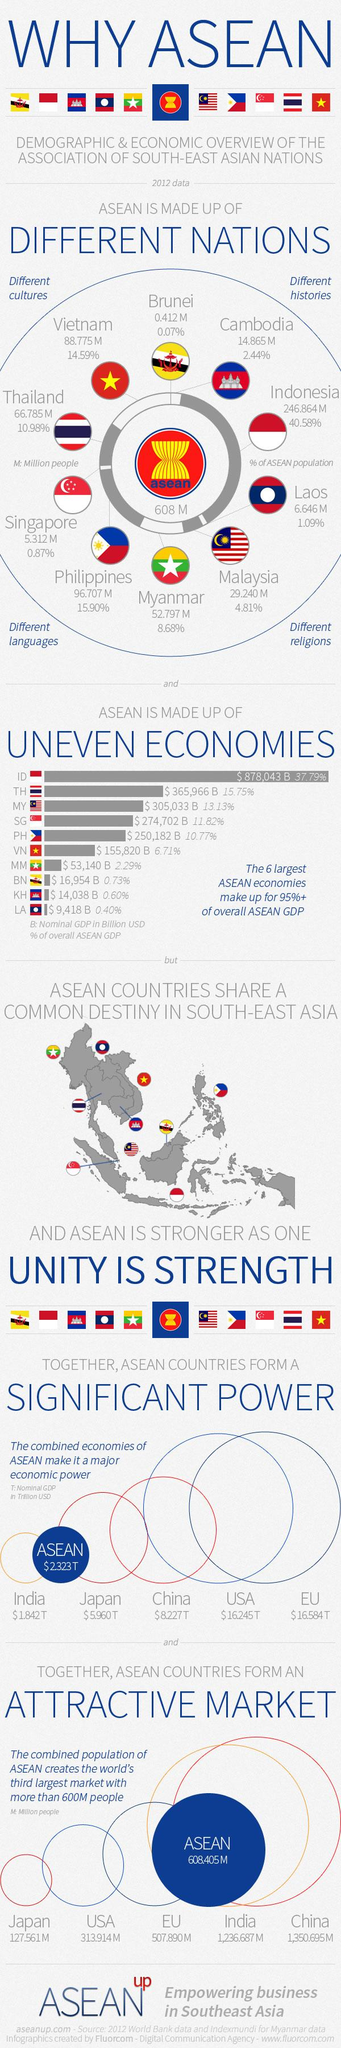List a handful of essential elements in this visual. According to the information provided, Brunei and Vietnam combined make up approximately 14.66% of the ASEAN region. According to the information provided, approximately 13.49% of ASEAN is made up of Malaysia and Myanmar taken together. 